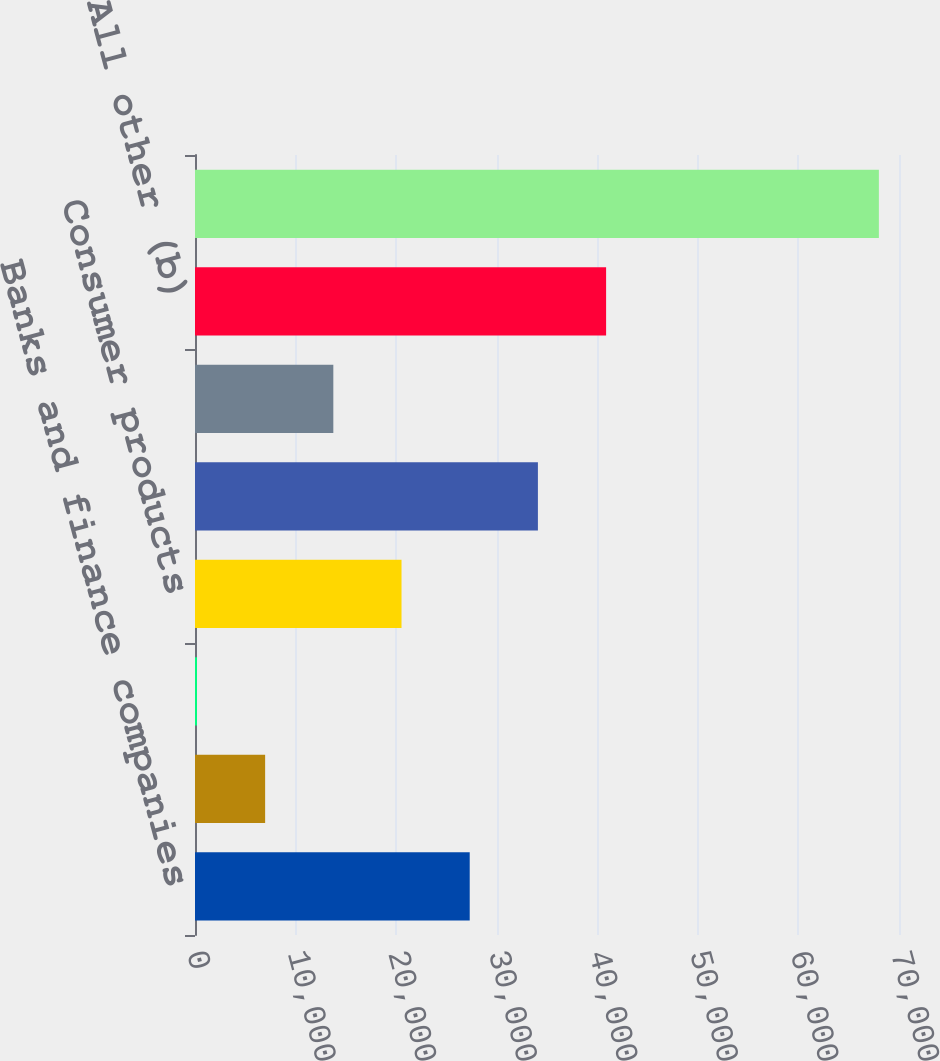<chart> <loc_0><loc_0><loc_500><loc_500><bar_chart><fcel>Banks and finance companies<fcel>Real estate<fcel>State and municipal<fcel>Consumer products<fcel>Utilities<fcel>Retail and consumer services<fcel>All other (b)<fcel>Total excluding loans<nl><fcel>27315.4<fcel>6973.6<fcel>193<fcel>20534.8<fcel>34096<fcel>13754.2<fcel>40876.6<fcel>67999<nl></chart> 